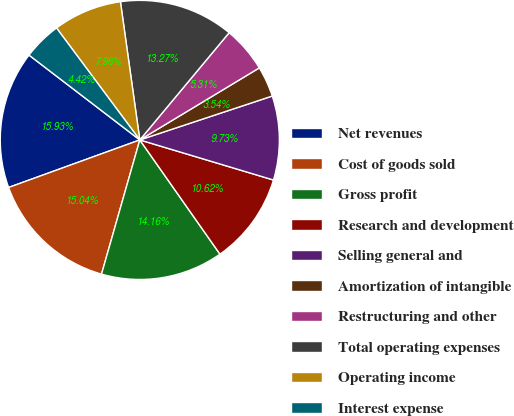Convert chart. <chart><loc_0><loc_0><loc_500><loc_500><pie_chart><fcel>Net revenues<fcel>Cost of goods sold<fcel>Gross profit<fcel>Research and development<fcel>Selling general and<fcel>Amortization of intangible<fcel>Restructuring and other<fcel>Total operating expenses<fcel>Operating income<fcel>Interest expense<nl><fcel>15.93%<fcel>15.04%<fcel>14.16%<fcel>10.62%<fcel>9.73%<fcel>3.54%<fcel>5.31%<fcel>13.27%<fcel>7.96%<fcel>4.42%<nl></chart> 